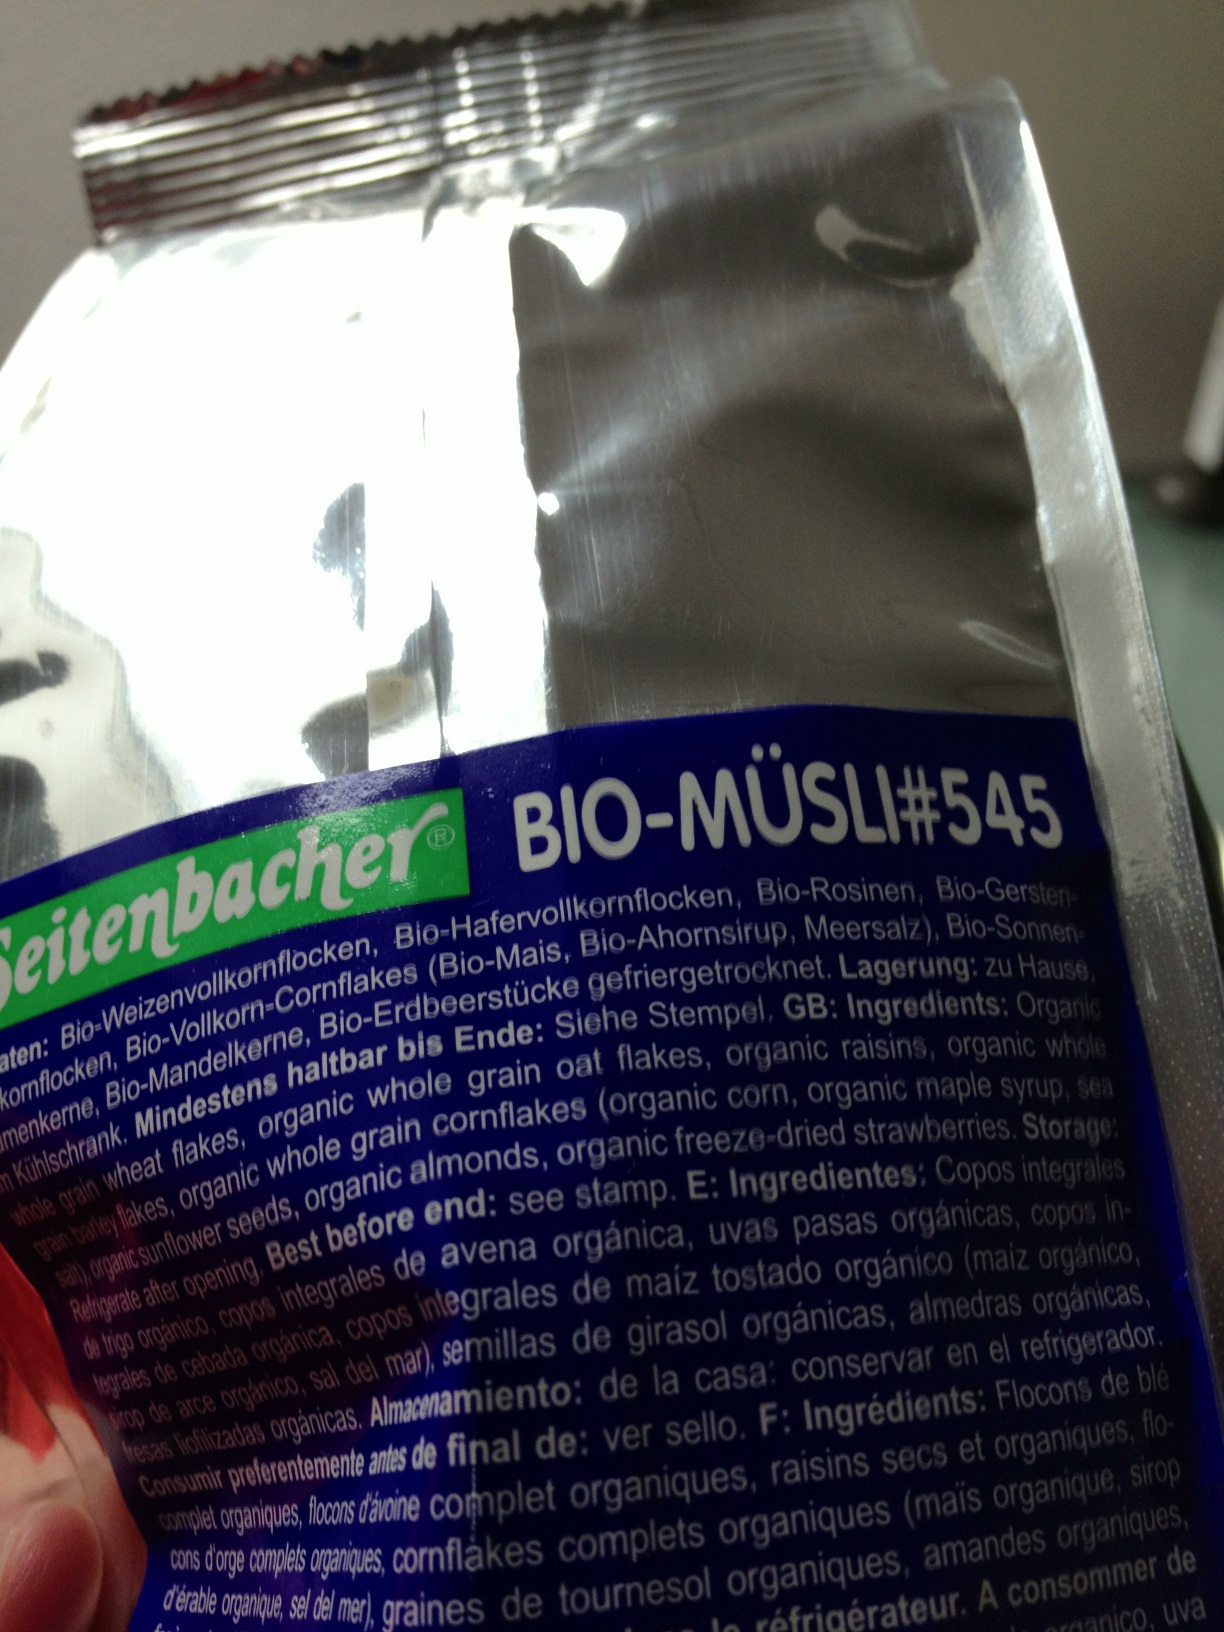What does the nutritional information say about sugars in this product? The image does not provide a clear view of the nutritional information, particularly regarding sugars. Typically, nutritional panels are on the back of these kinds of packages. For accurate details, please refer to the nutritional label on the package itself. Could you tell me more about allergy information provided? Without a visible allergy information section in the image, I recommend checking the package thoroughly, often found near the ingredient list. Manufacturers usually highlight allergen information for safety. 